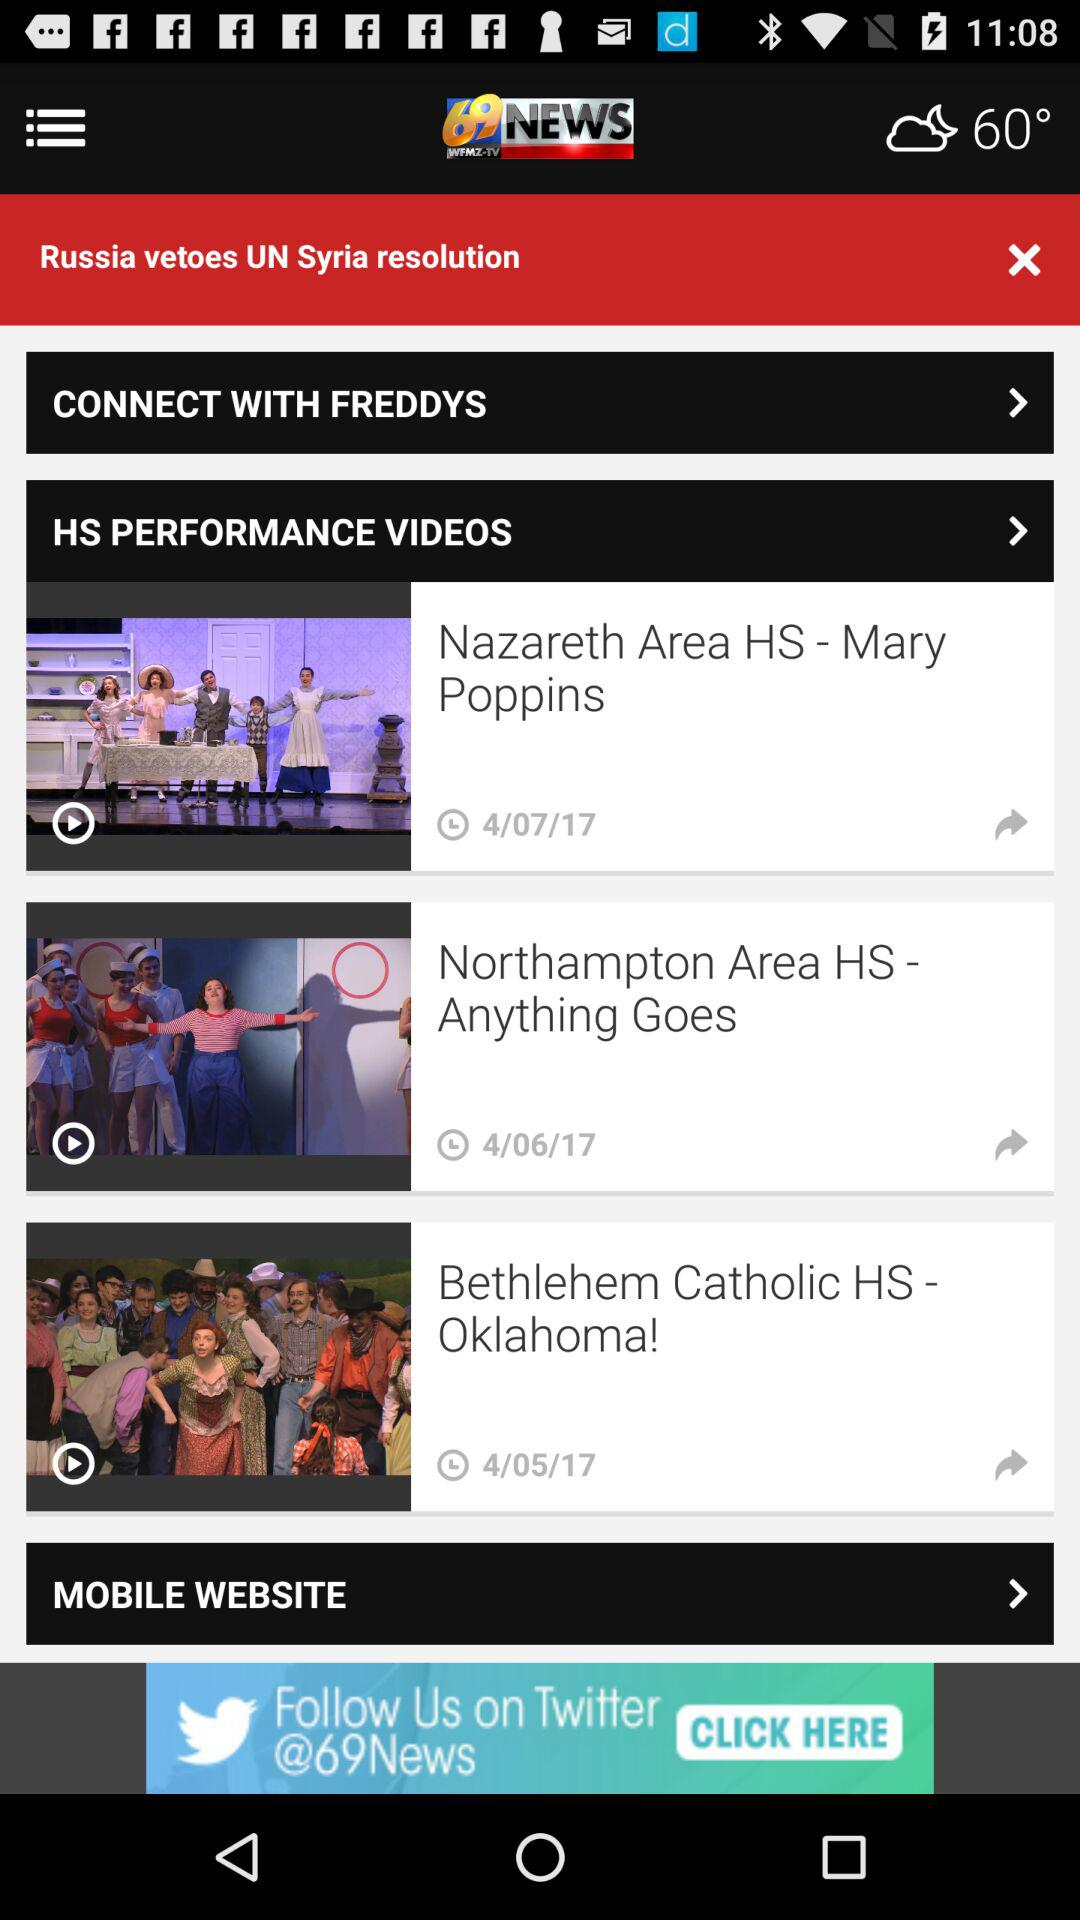When was the video "Northampton Area HS - Anything Goes" uploaded? The video was uploaded on April 6, 2017. 